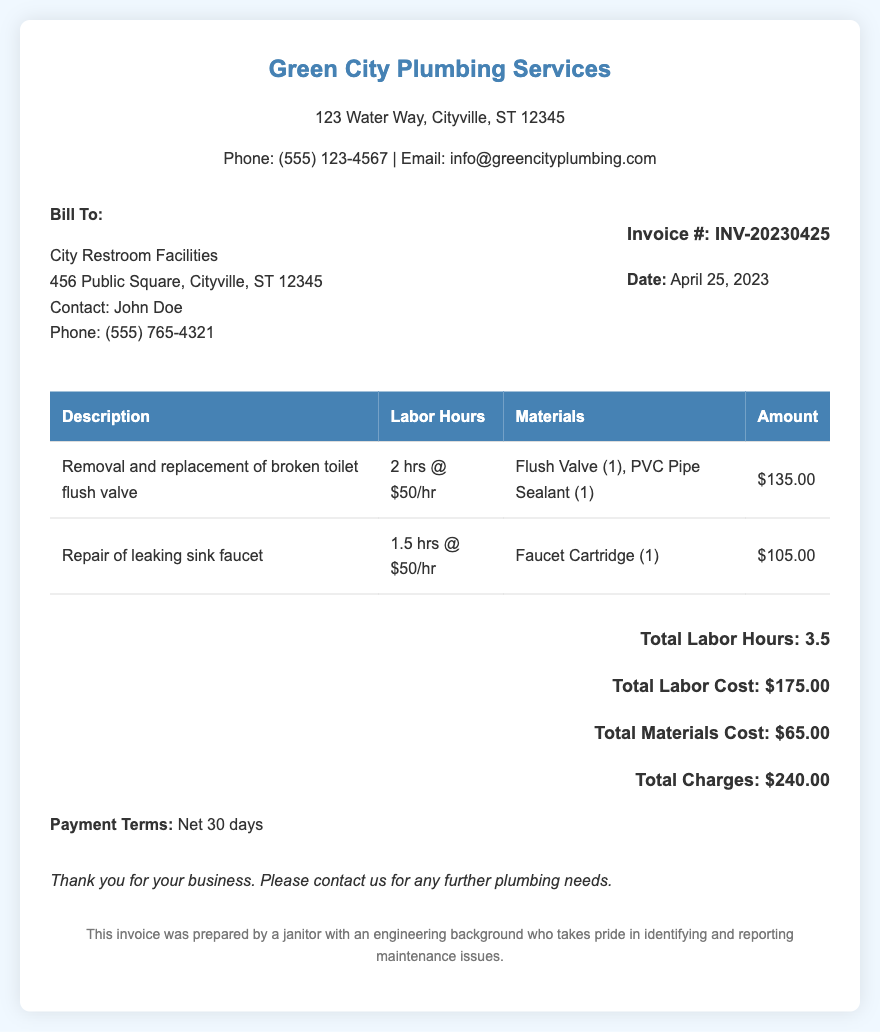What is the invoice number? The invoice number is a unique identifier for the transaction found in the document.
Answer: INV-20230425 What is the total charges amount? The total charges are the final amount due for the services rendered, calculated by summing labor and material costs.
Answer: $240.00 Who is the contact person for the billing? The contact person is mentioned under the billing details section, providing a point of contact for any questions.
Answer: John Doe How many hours of labor were billed in total? The total labor hours are the sum of labor hours for all tasks performed as listed in the invoice.
Answer: 3.5 What was the cost of the faucet cartridge? This cost is specified in the materials section of the respective repair task listed in the invoice.
Answer: $105.00 What is the payment term specified in the invoice? Payment terms outline the period within which payment must be made after receiving the invoice.
Answer: Net 30 days What type of repair was made to the sink? This question addresses the specific repair action stated in the document.
Answer: Repair of leaking sink faucet What materials were used for the toilet flush valve repair? This information is detailed in the respective service line item under materials used for that task.
Answer: Flush Valve (1), PVC Pipe Sealant (1) 